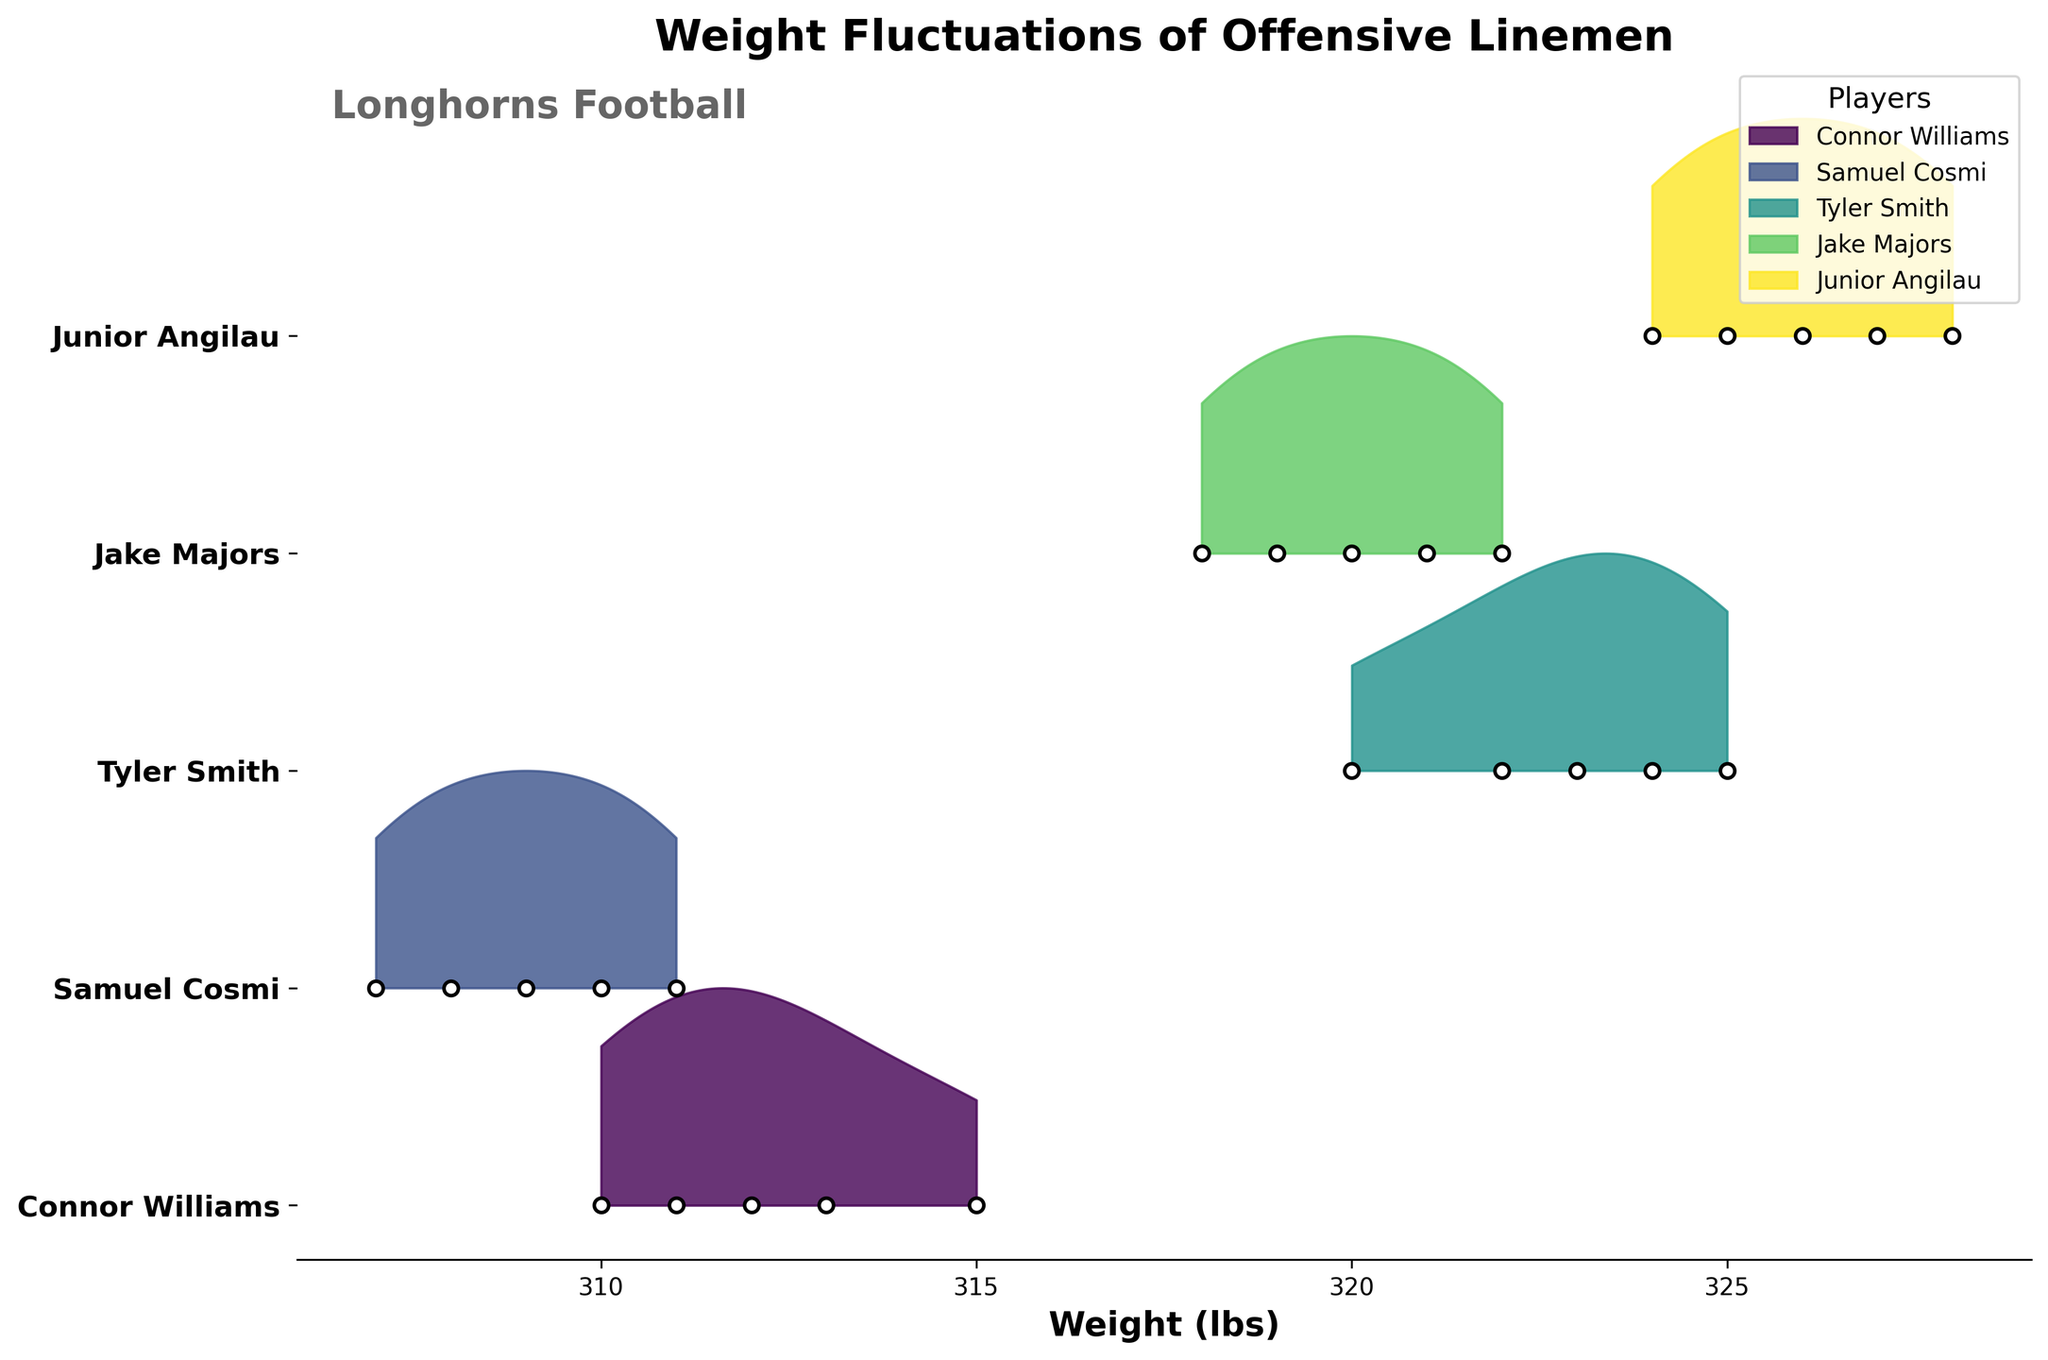What is the title of the figure? The title is located at the top center of the plot. It should provide a general idea about the content of the figure.
Answer: Weight Fluctuations of Offensive Linemen How many players are represented in the plot? Each player is represented on the y-axis with their names listed. By counting the unique names, we can determine the number of players.
Answer: 5 Which player shows the most variability in weight? To determine this, look for the player whose weight distribution (kde bandwidth) covers the broadest range on the x-axis. This indicates more fluctuations in weight.
Answer: Junior Angilau What is the general trend of Samuel Cosmi's weight over the season? By examining the weight points plotted for Samuel Cosmi, we can observe the approximate trend (increasing, decreasing, or stable) over the specified weeks.
Answer: Slightly decreasing Which player had the highest weight point at any given week? Identify the highest weight value on the x-axis and then see which player's points reach that value.
Answer: Junior Angilau (328 lbs) How does Tyler Smith's weight fluctuate over the season compared to Jake Majors? By comparing the weight points and density plots for both Tyler Smith and Jake Majors, we can assess which player has more significant or stable fluctuations.
Answer: Tyler Smith fluctuates more What week did Connor Williams reach his lowest weight? By examining Connor William’s data points on the plot, identify the week corresponding to the minimum weight value.
Answer: Week 8 Which two players have the most similar weight distributions? Look at the density plots (shapes and ranges). The most similar distributions will have similar shapes and overlapping areas.
Answer: Jake Majors and Samuel Cosmi Does any player display a notable drop or gain in weight mid-season? Observe if any player's weight points show a noticeable change, either up or down, around the midpoint (week 8).
Answer: Samuel Cosmi shows a notable drop What is the average weight of Connor Williams throughout the season? Sum all weight values of Connor Williams over the weeks and then divide by the number of weeks to get the average.
Answer: (315 + 312 + 310 + 313 + 311) / 5 = 312.2 